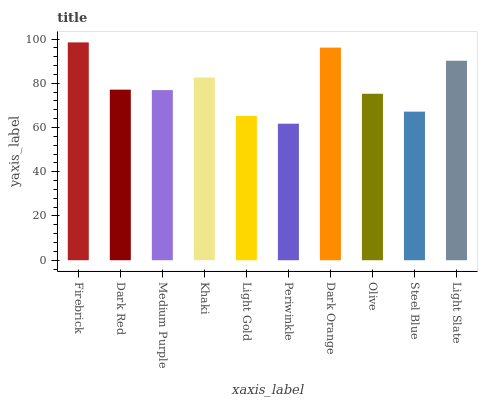Is Dark Red the minimum?
Answer yes or no. No. Is Dark Red the maximum?
Answer yes or no. No. Is Firebrick greater than Dark Red?
Answer yes or no. Yes. Is Dark Red less than Firebrick?
Answer yes or no. Yes. Is Dark Red greater than Firebrick?
Answer yes or no. No. Is Firebrick less than Dark Red?
Answer yes or no. No. Is Dark Red the high median?
Answer yes or no. Yes. Is Medium Purple the low median?
Answer yes or no. Yes. Is Periwinkle the high median?
Answer yes or no. No. Is Khaki the low median?
Answer yes or no. No. 